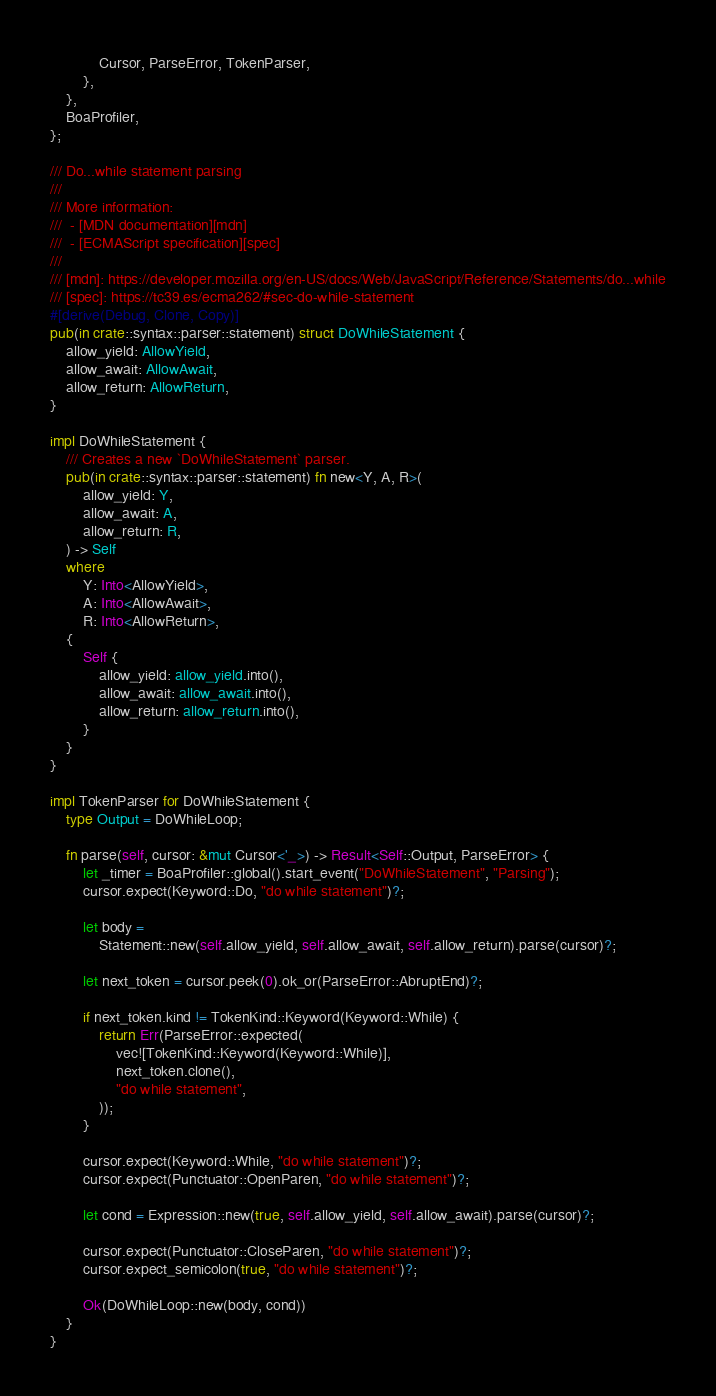Convert code to text. <code><loc_0><loc_0><loc_500><loc_500><_Rust_>            Cursor, ParseError, TokenParser,
        },
    },
    BoaProfiler,
};

/// Do...while statement parsing
///
/// More information:
///  - [MDN documentation][mdn]
///  - [ECMAScript specification][spec]
///
/// [mdn]: https://developer.mozilla.org/en-US/docs/Web/JavaScript/Reference/Statements/do...while
/// [spec]: https://tc39.es/ecma262/#sec-do-while-statement
#[derive(Debug, Clone, Copy)]
pub(in crate::syntax::parser::statement) struct DoWhileStatement {
    allow_yield: AllowYield,
    allow_await: AllowAwait,
    allow_return: AllowReturn,
}

impl DoWhileStatement {
    /// Creates a new `DoWhileStatement` parser.
    pub(in crate::syntax::parser::statement) fn new<Y, A, R>(
        allow_yield: Y,
        allow_await: A,
        allow_return: R,
    ) -> Self
    where
        Y: Into<AllowYield>,
        A: Into<AllowAwait>,
        R: Into<AllowReturn>,
    {
        Self {
            allow_yield: allow_yield.into(),
            allow_await: allow_await.into(),
            allow_return: allow_return.into(),
        }
    }
}

impl TokenParser for DoWhileStatement {
    type Output = DoWhileLoop;

    fn parse(self, cursor: &mut Cursor<'_>) -> Result<Self::Output, ParseError> {
        let _timer = BoaProfiler::global().start_event("DoWhileStatement", "Parsing");
        cursor.expect(Keyword::Do, "do while statement")?;

        let body =
            Statement::new(self.allow_yield, self.allow_await, self.allow_return).parse(cursor)?;

        let next_token = cursor.peek(0).ok_or(ParseError::AbruptEnd)?;

        if next_token.kind != TokenKind::Keyword(Keyword::While) {
            return Err(ParseError::expected(
                vec![TokenKind::Keyword(Keyword::While)],
                next_token.clone(),
                "do while statement",
            ));
        }

        cursor.expect(Keyword::While, "do while statement")?;
        cursor.expect(Punctuator::OpenParen, "do while statement")?;

        let cond = Expression::new(true, self.allow_yield, self.allow_await).parse(cursor)?;

        cursor.expect(Punctuator::CloseParen, "do while statement")?;
        cursor.expect_semicolon(true, "do while statement")?;

        Ok(DoWhileLoop::new(body, cond))
    }
}
</code> 